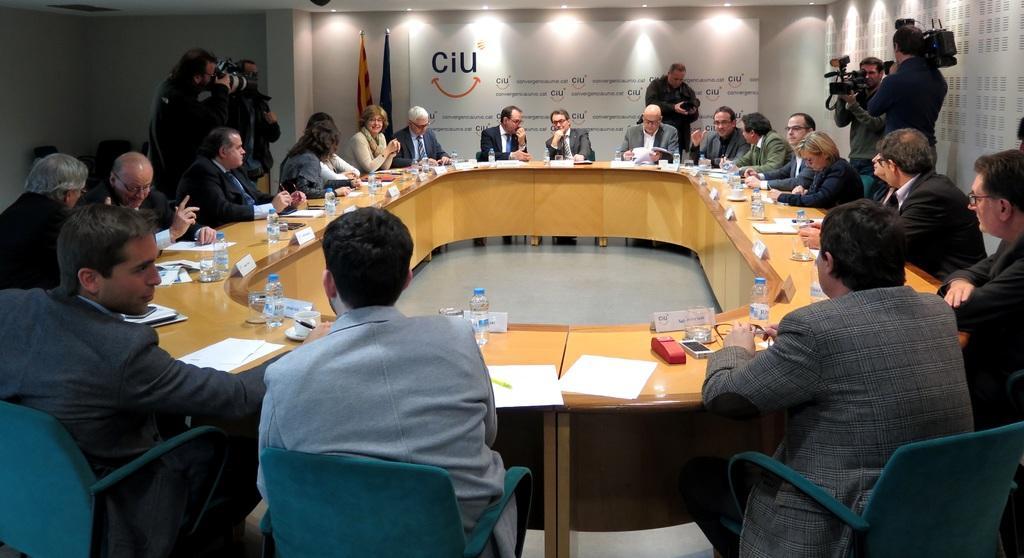Could you give a brief overview of what you see in this image? In this picture there are a group of people sitting in a circular manner and discussing 